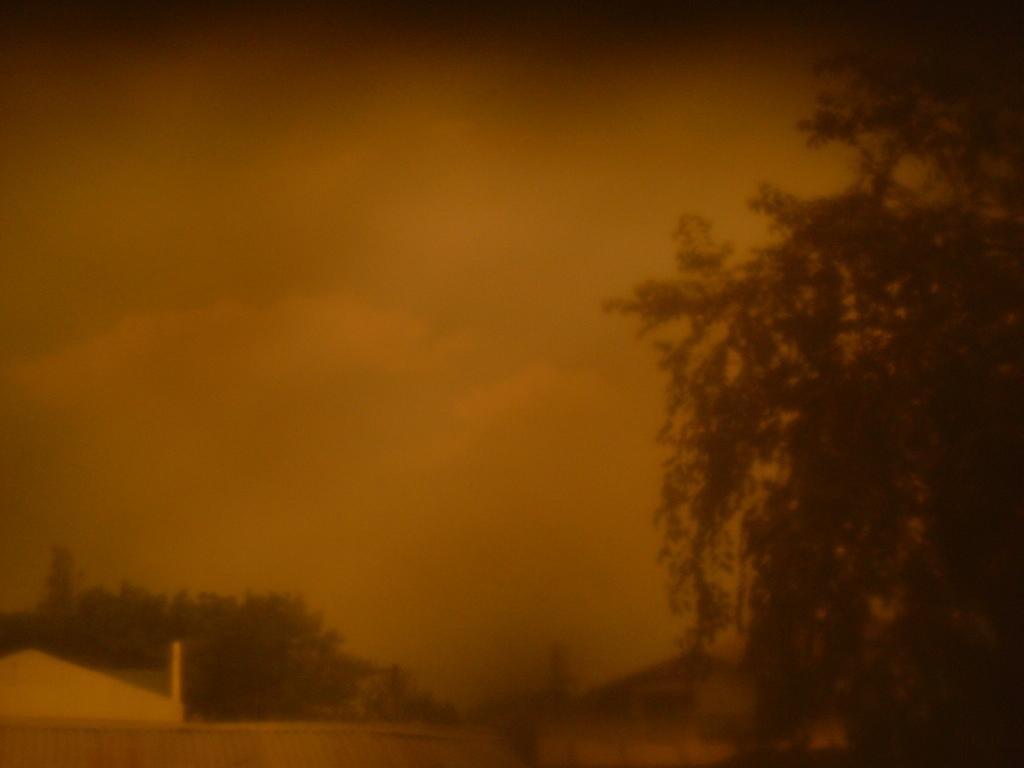What type of vegetation can be seen in the image? There are trees in the image. How would you describe the background of the image? The background of the image is blurred. Is your sister participating in a competition with the trees in the image? There is no mention of a sister or a competition in the image, so we cannot answer that question. 